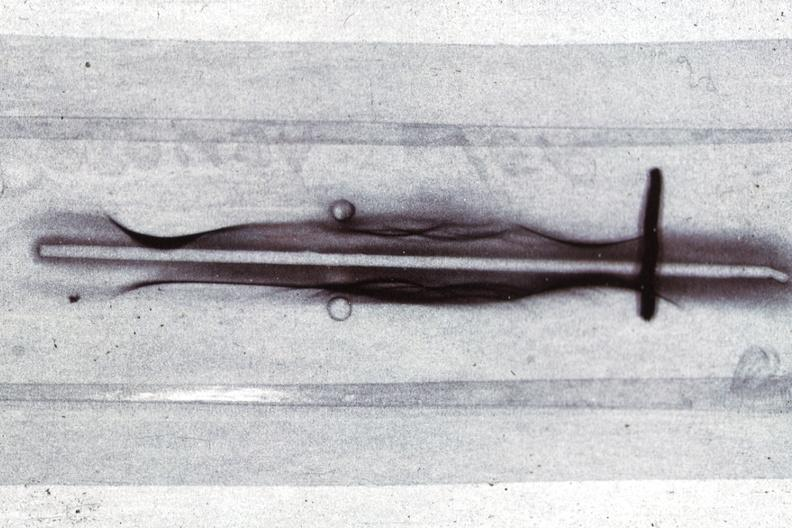s blood present?
Answer the question using a single word or phrase. Yes 